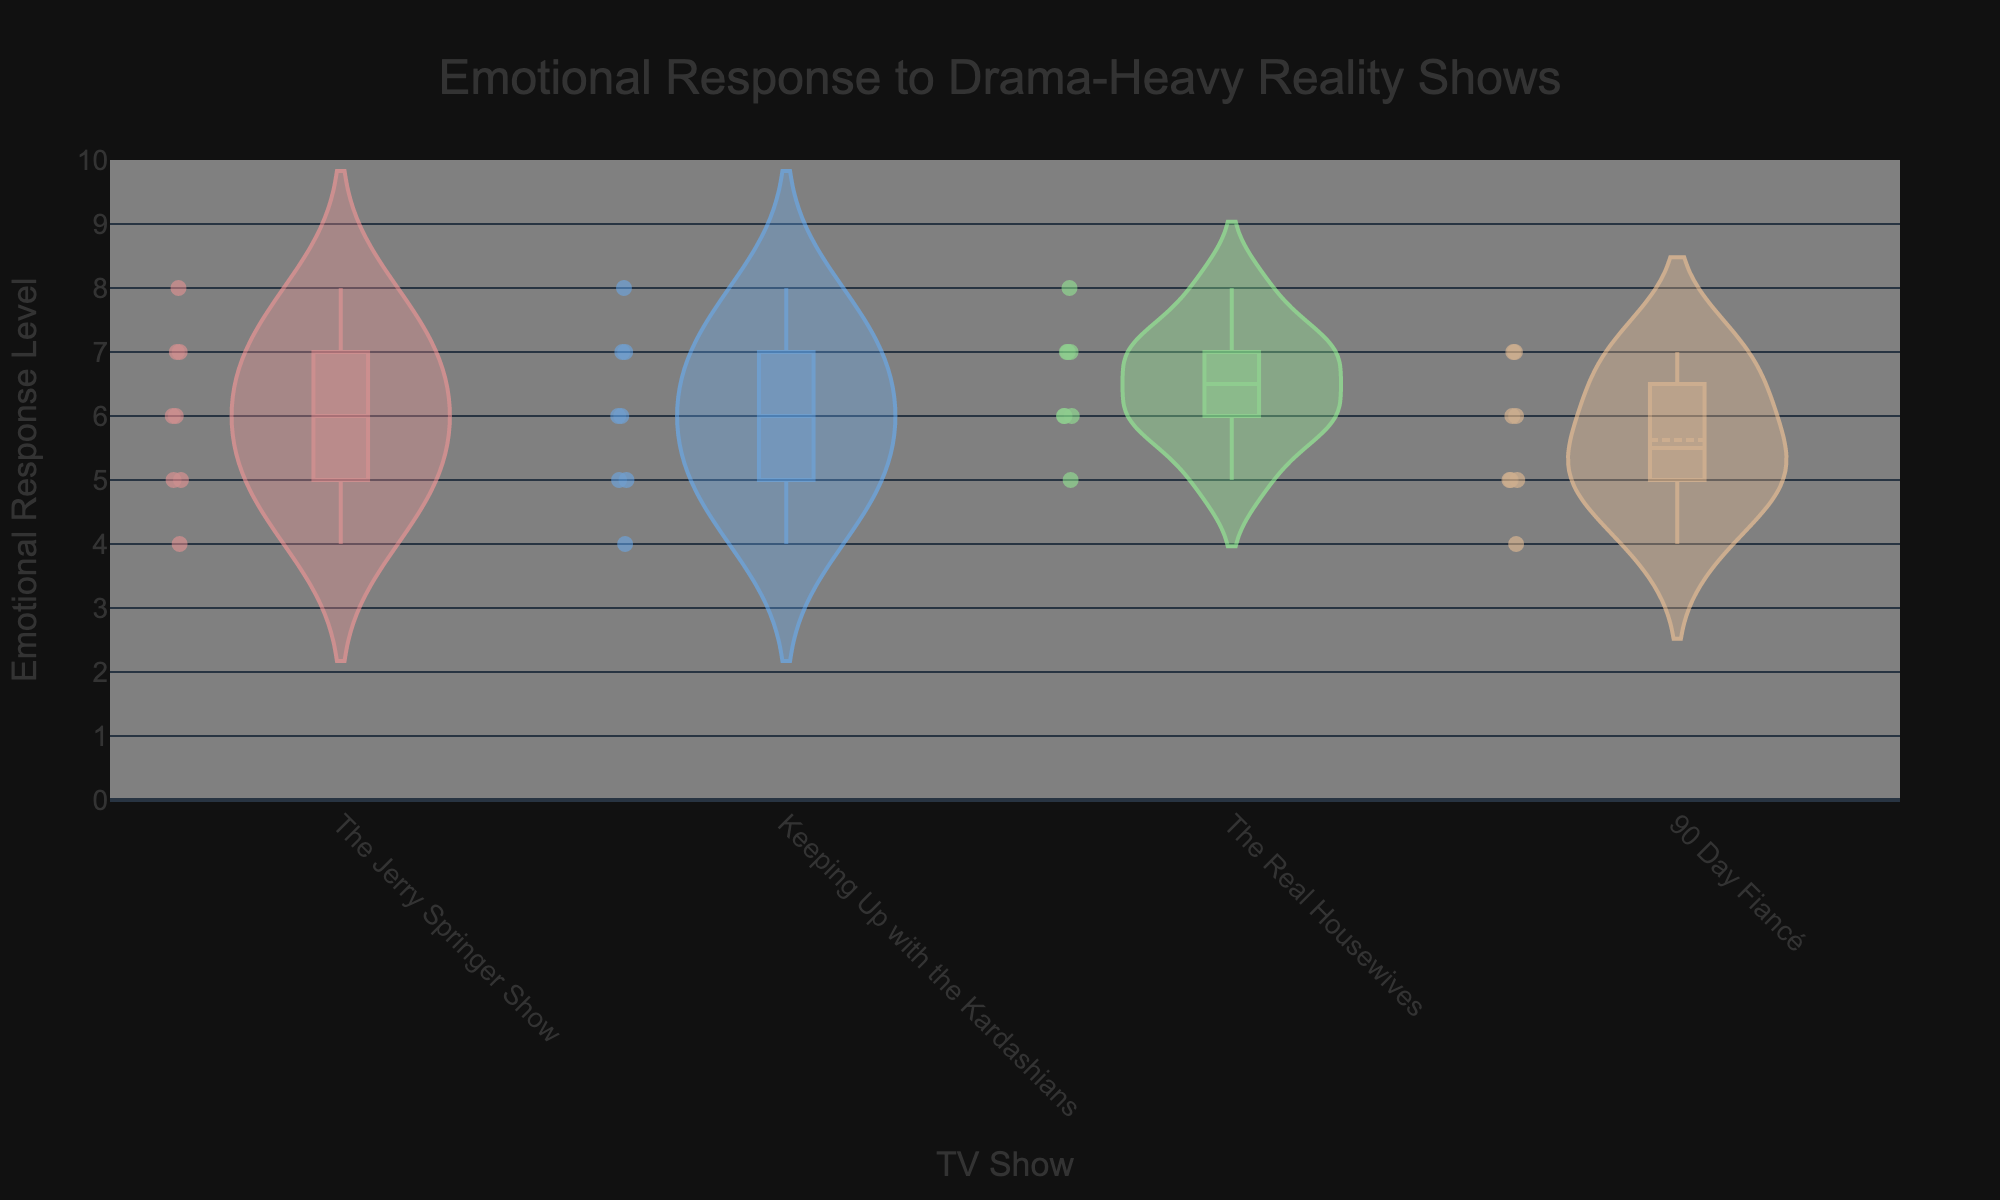What is the title of the plot? The title is located at the top-center of the plot.
Answer: Emotional Response to Drama-Heavy Reality Shows Which show has the widest distribution of emotional response levels? Looking at the width of the violin plots and the spread of points, "The Real Housewives" seems to have the widest distribution.
Answer: The Real Housewives How many emotional responses are recorded for "90 Day Fiancé"? By counting the number of individual points within the violin plot for "90 Day Fiancé".
Answer: 8 Which show has the highest median emotional response level? The median is indicated by the white dot in each violin plot. "The Real Housewives" has the highest median value.
Answer: The Real Housewives What is the range of emotional response levels for "The Jerry Springer Show"? The range is given by the span between the minimum and maximum points in the violin plot for "The Jerry Springer Show". The levels go from 4 to 8.
Answer: 4 to 8 What's the average emotional response level across all shows? Calculate the average by summing all recorded emotional response levels and dividing by the total number of data points: (7+5+8+6+4+6+5+7+6+7+8+7+5+6+4+5+7+6+5+6+7+8+6+7+5+7+6+7+5+6+4+5)/32.
Answer: 6.0625 Which show has the least variability in emotional response levels? Variability can be judged by the width and spread of the violin plots. "Keeping Up with the Kardashians" appears to have a more condensed distribution.
Answer: Keeping Up with the Kardashians Is the emotional response level typically higher in older or younger viewers? By looking at the distribution of points within each violin plot, it seems that the higher emotional response levels tend to be more frequent in older age groups.
Answer: Older viewers Which show has the lowest mean emotional response level? The mean is indicated by the dashed line in each violin plot. "The Jerry Springer Show" has the lowest mean emotional response level.
Answer: The Jerry Springer Show 